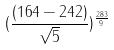<formula> <loc_0><loc_0><loc_500><loc_500>( \frac { ( 1 6 4 - 2 4 2 ) } { \sqrt { 5 } } ) ^ { \frac { 2 8 3 } { 9 } }</formula> 